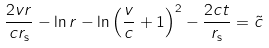Convert formula to latex. <formula><loc_0><loc_0><loc_500><loc_500>\frac { 2 v r } { c r _ { \mathrm s } } - \ln r - \ln \left ( \frac { v } { c } + 1 \right ) ^ { 2 } - \frac { 2 c t } { r _ { \mathrm s } } = { \tilde { c } }</formula> 